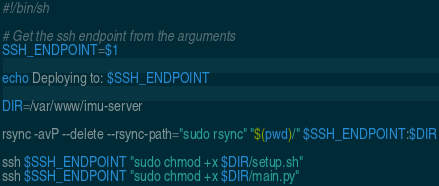<code> <loc_0><loc_0><loc_500><loc_500><_Bash_>#!/bin/sh

# Get the ssh endpoint from the arguments
SSH_ENDPOINT=$1

echo Deploying to: $SSH_ENDPOINT

DIR=/var/www/imu-server

rsync -avP --delete --rsync-path="sudo rsync" "$(pwd)/" $SSH_ENDPOINT:$DIR

ssh $SSH_ENDPOINT "sudo chmod +x $DIR/setup.sh"
ssh $SSH_ENDPOINT "sudo chmod +x $DIR/main.py"
</code> 